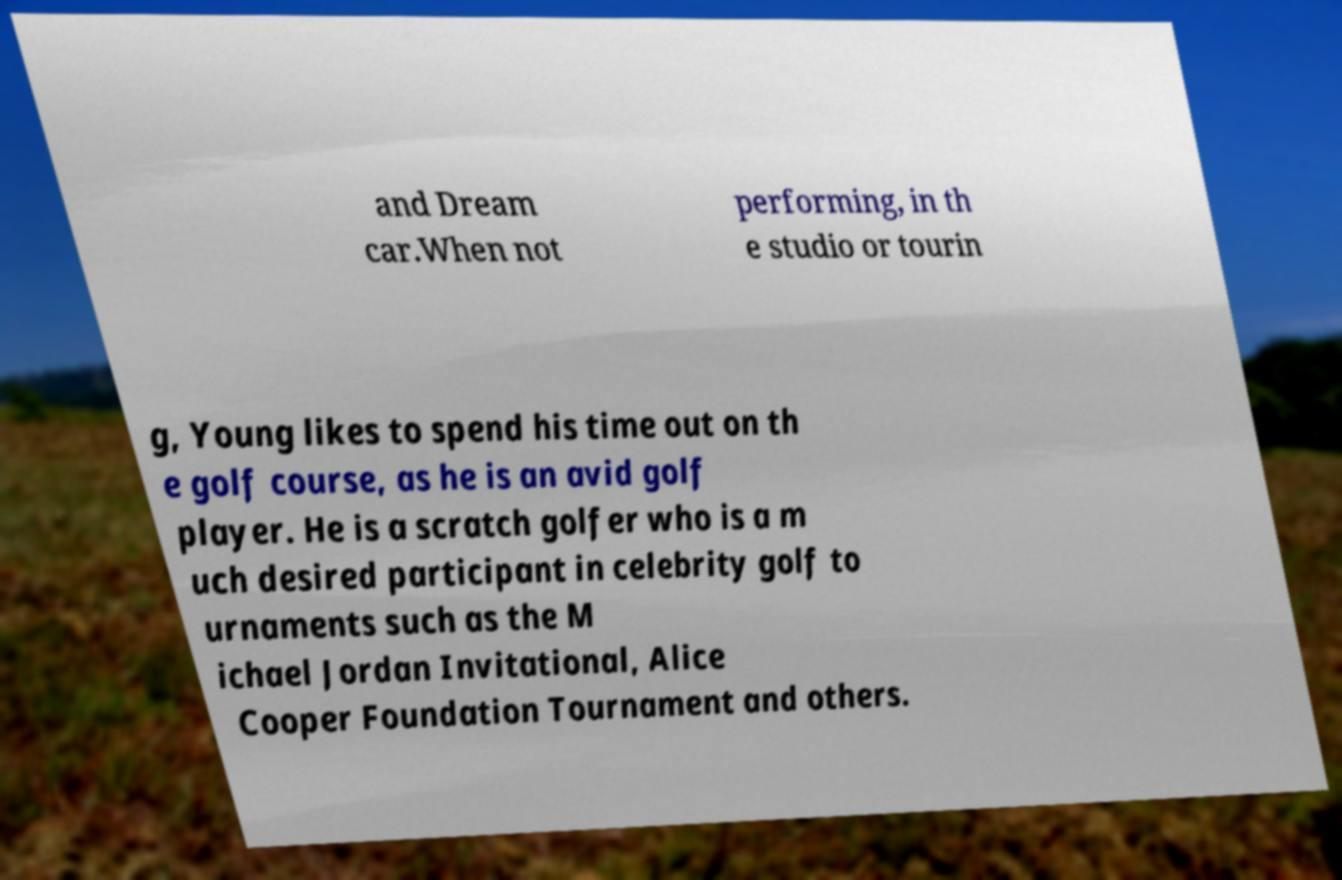Could you extract and type out the text from this image? and Dream car.When not performing, in th e studio or tourin g, Young likes to spend his time out on th e golf course, as he is an avid golf player. He is a scratch golfer who is a m uch desired participant in celebrity golf to urnaments such as the M ichael Jordan Invitational, Alice Cooper Foundation Tournament and others. 